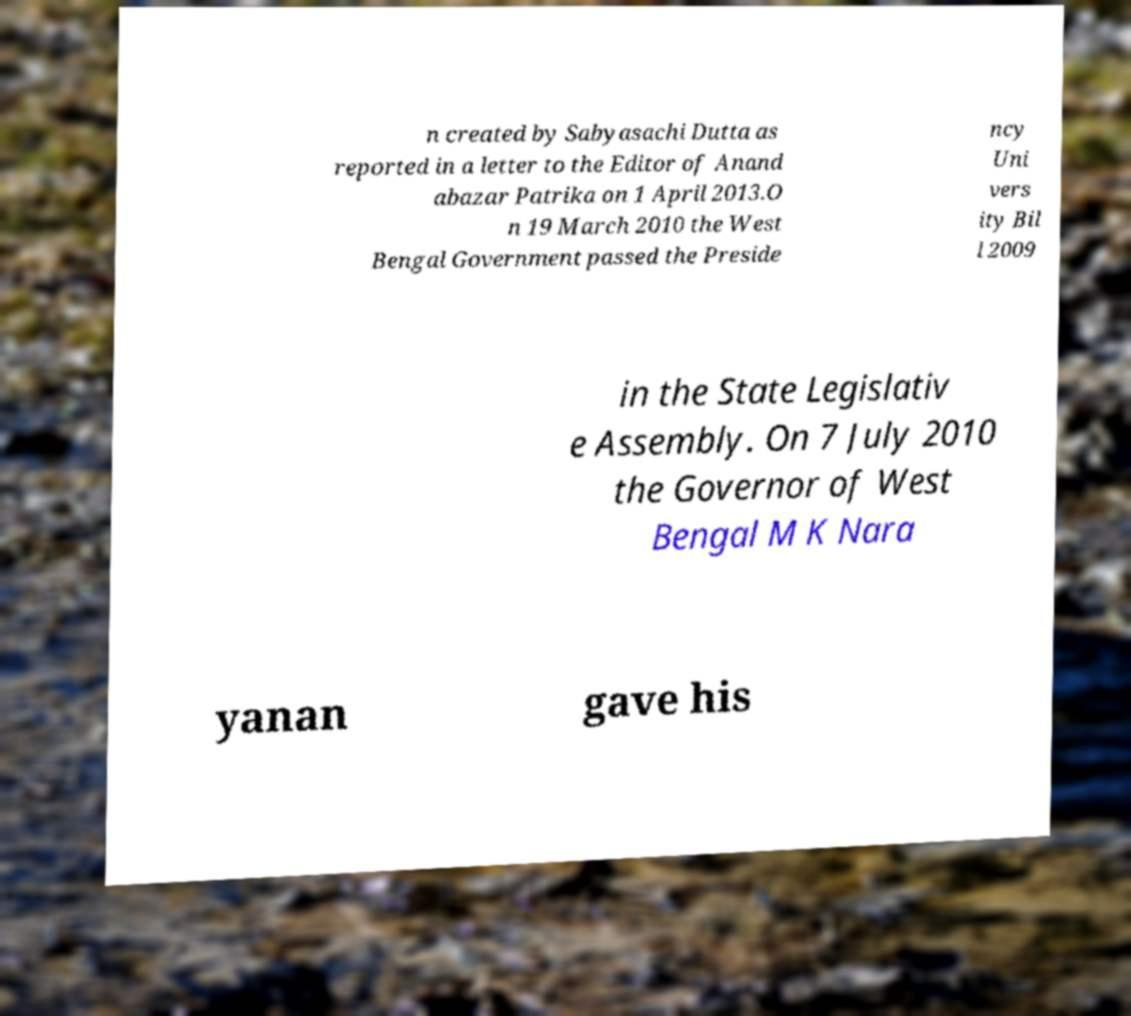I need the written content from this picture converted into text. Can you do that? n created by Sabyasachi Dutta as reported in a letter to the Editor of Anand abazar Patrika on 1 April 2013.O n 19 March 2010 the West Bengal Government passed the Preside ncy Uni vers ity Bil l 2009 in the State Legislativ e Assembly. On 7 July 2010 the Governor of West Bengal M K Nara yanan gave his 